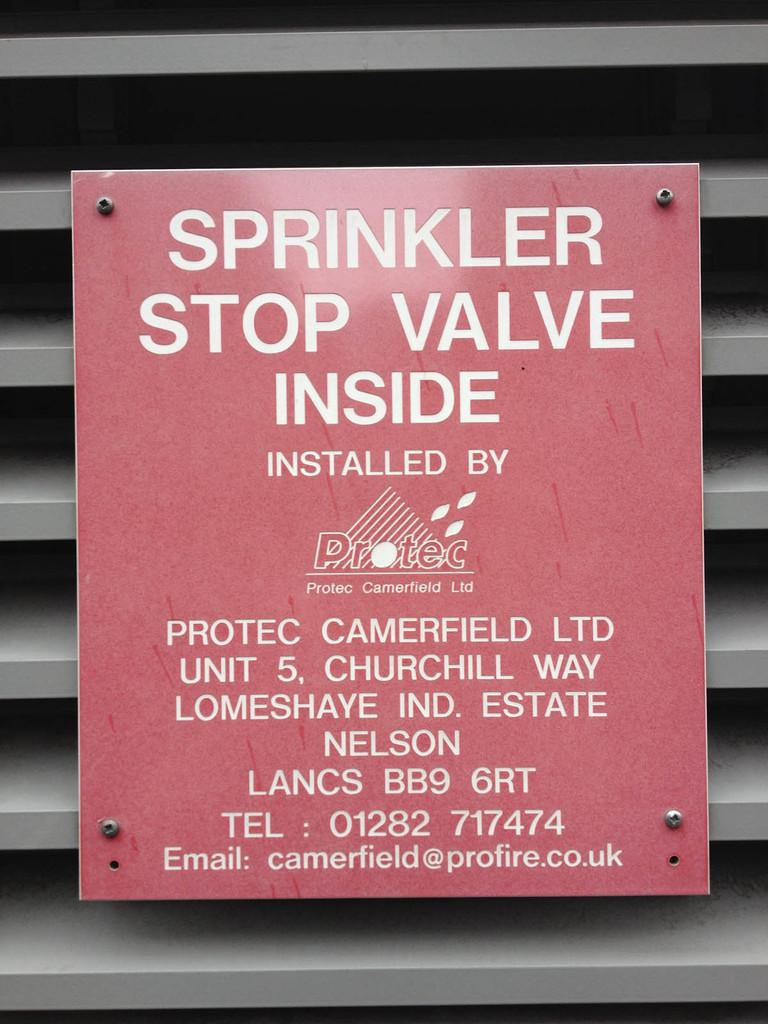<image>
Present a compact description of the photo's key features. A sprinkler stop valve was installed by Protec. 